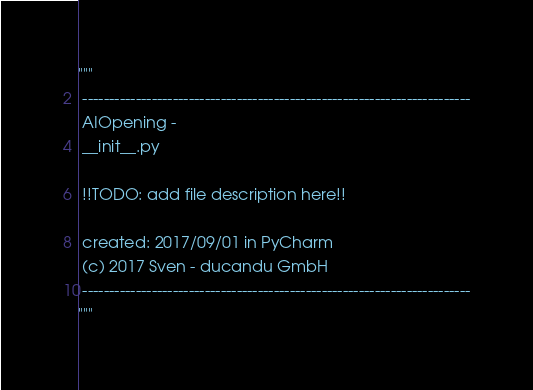<code> <loc_0><loc_0><loc_500><loc_500><_Python_>"""
 -------------------------------------------------------------------------
 AIOpening - 
 __init__.py
 
 !!TODO: add file description here!! 
  
 created: 2017/09/01 in PyCharm
 (c) 2017 Sven - ducandu GmbH
 -------------------------------------------------------------------------
"""</code> 